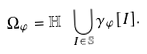Convert formula to latex. <formula><loc_0><loc_0><loc_500><loc_500>\Omega _ { \varphi } = \mathbb { H } \ \bigcup _ { I \in \mathbb { S } } \gamma _ { \varphi } [ I ] .</formula> 